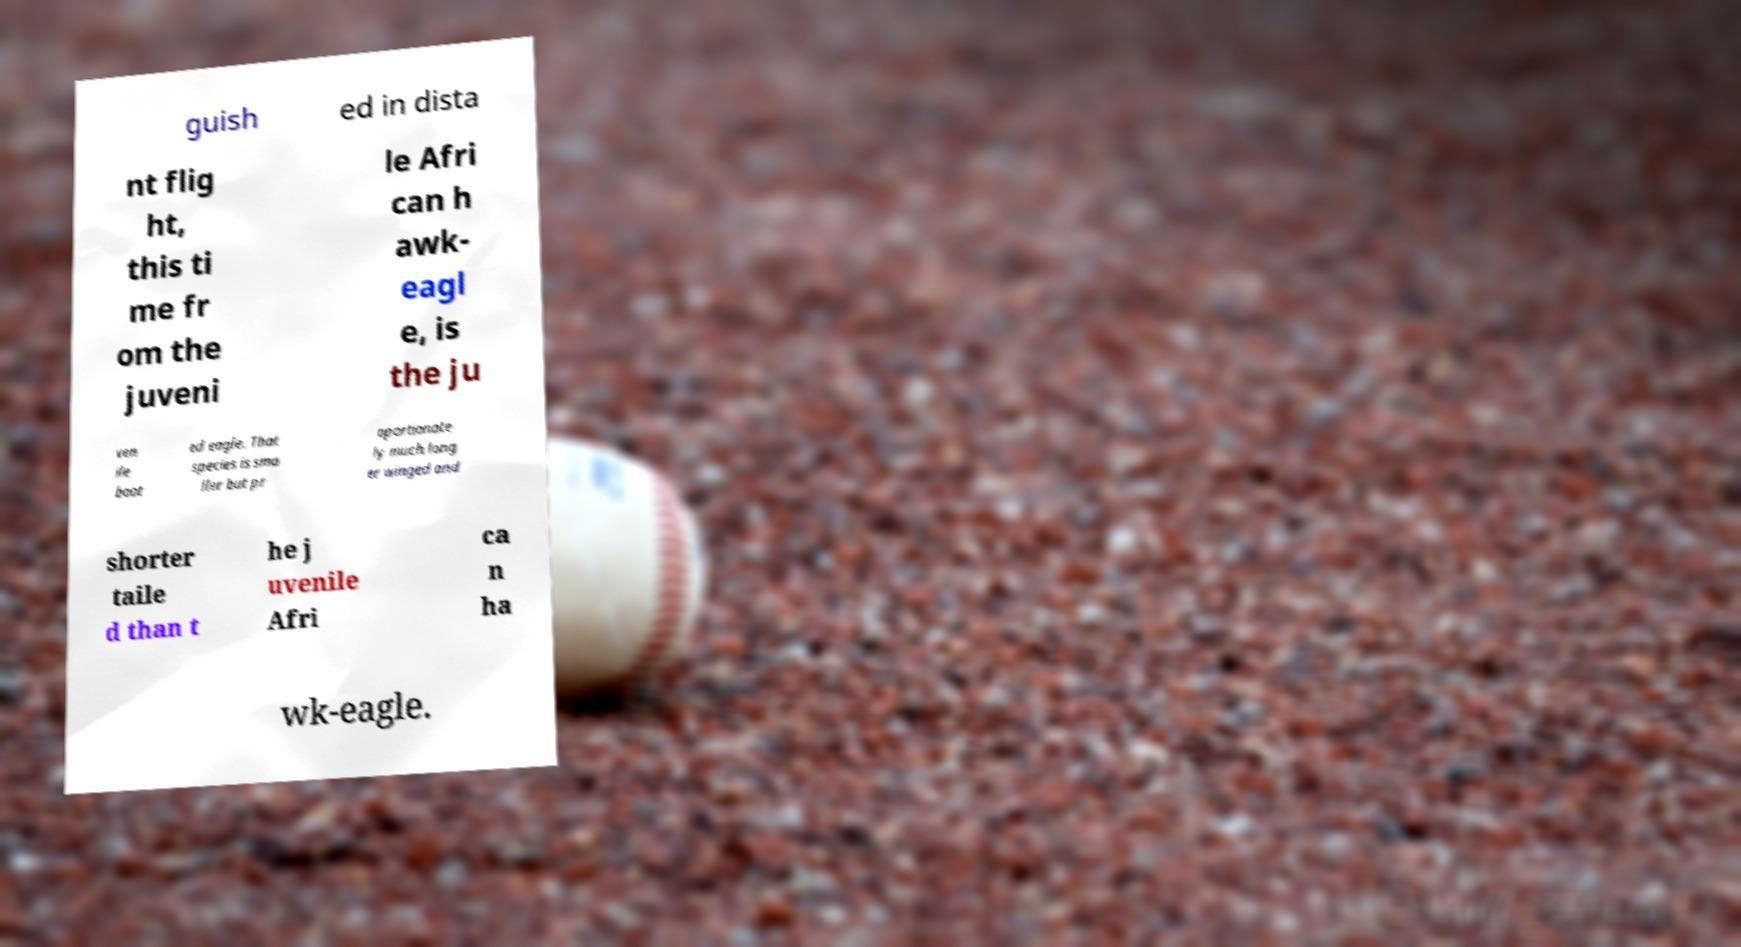Could you extract and type out the text from this image? guish ed in dista nt flig ht, this ti me fr om the juveni le Afri can h awk- eagl e, is the ju ven ile boot ed eagle. That species is sma ller but pr oportionate ly much long er winged and shorter taile d than t he j uvenile Afri ca n ha wk-eagle. 